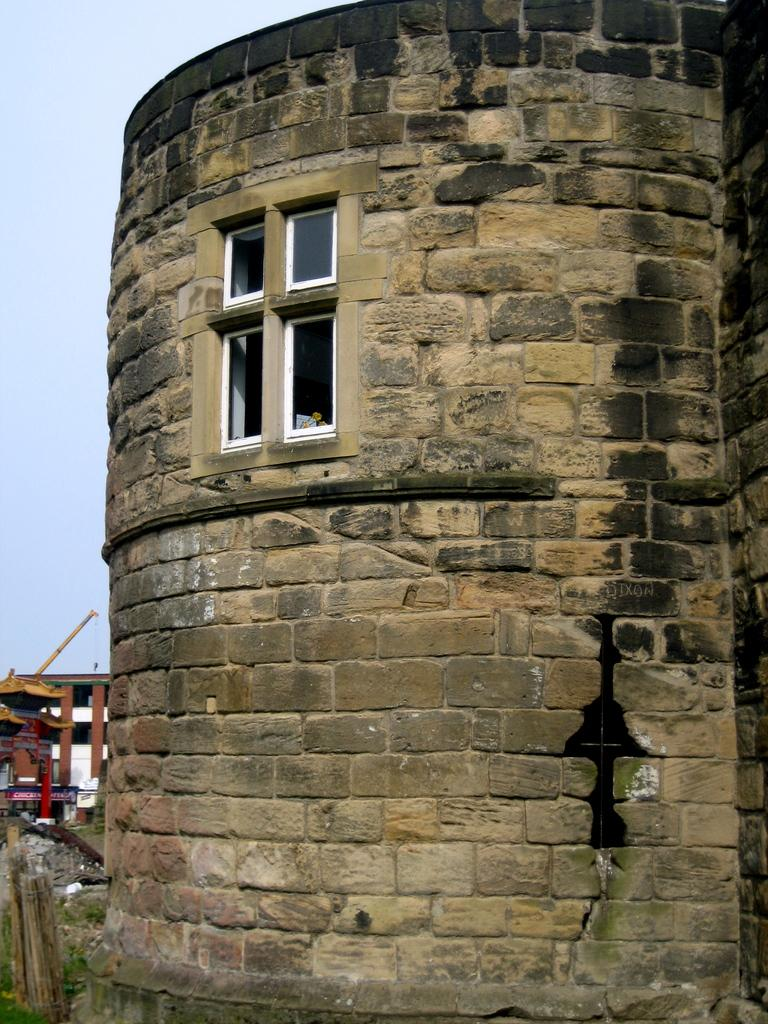What structure is located on the right side of the image? There is a building on the right side of the image. What feature of the building is mentioned in the facts? The building has windows. What can be seen on the left side of the image? There is a roof on the left side of the image. How is the glue being used in the image? There is no glue present in the image. What type of grape is growing on the roof in the image? There are no grapes present in the image, and the roof is not described as having any vegetation. 